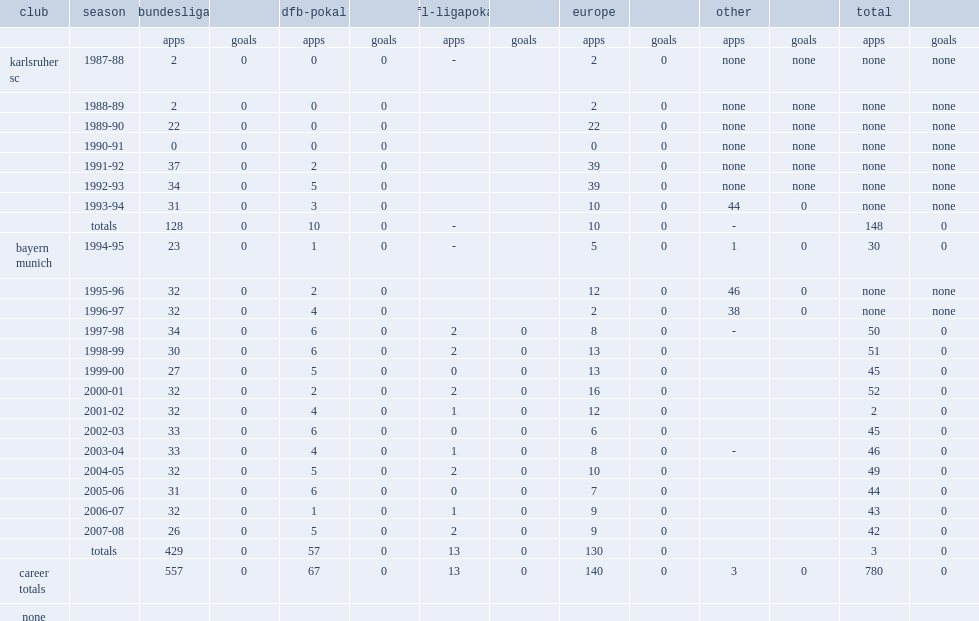How many appearances did oliver kahn have in total? 557.0. 